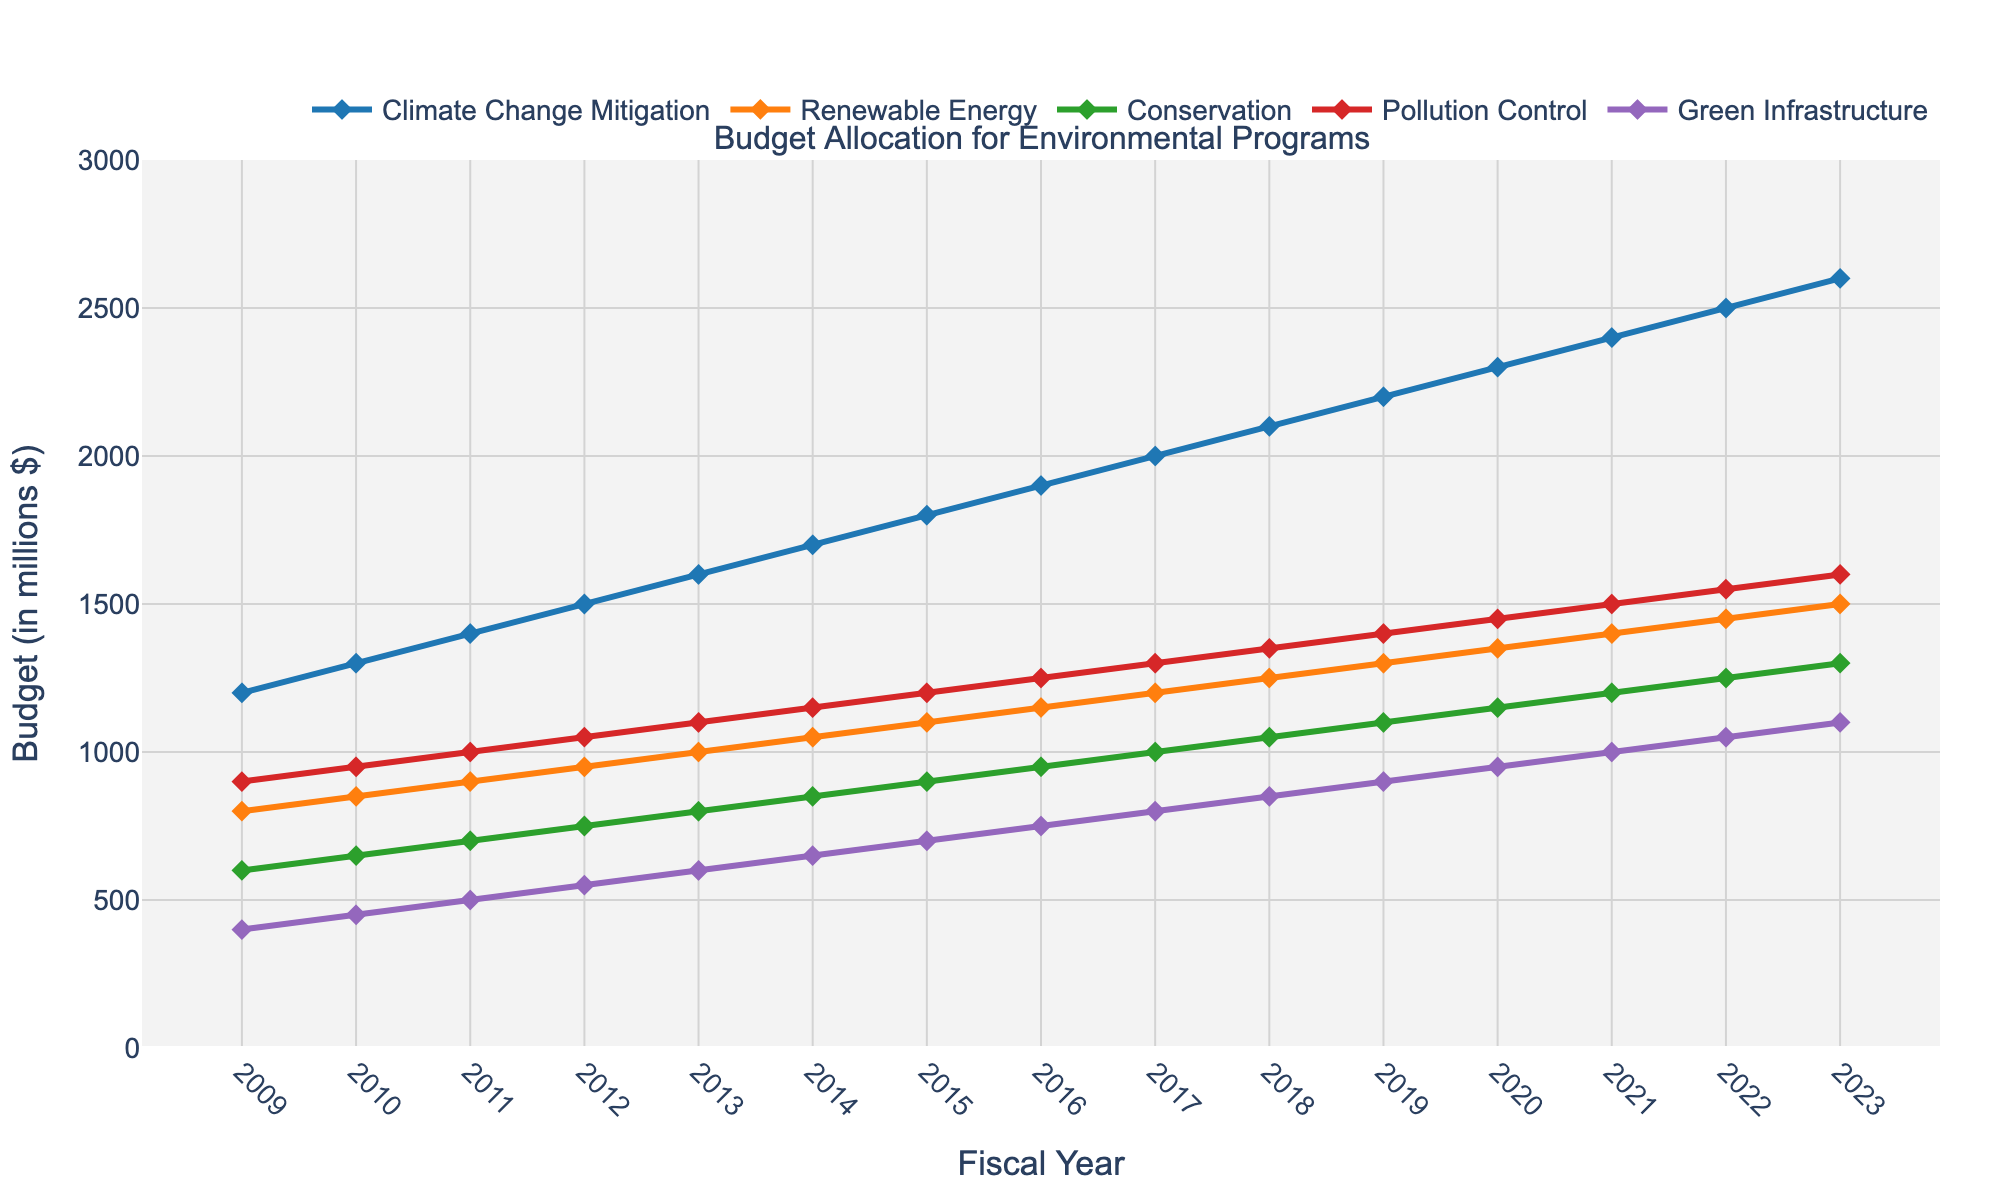What is the total budget allocated for Climate Change Mitigation in the first five fiscal years? To find the total budget for Climate Change Mitigation in the first five years, sum the values from 2009 to 2013: 1200 + 1300 + 1400 + 1500 + 1600 = 7000
Answer: 7000 Which year saw the largest budget increase for Renewable Energy when compared to the previous year? To identify the largest budget increase for Renewable Energy, compare the yearly differences: 
2010-2009 = 50, 
2011-2010 = 50, 
2012-2011 = 50, 
2013-2012 = 50, 
2014-2013 = 50, 
2015-2014 = 50, 
2016-2015 = 50, 
2017-2016 = 50, 
2018-2017 = 50, 
2019-2018 = 50, 
2020-2019 = 50, 
2021-2020 = 50, 
2022-2021 = 50, 
2023-2022 = 50. All the differences are equal, so any year can be chosen.
Answer: Any year from 2010 to 2023 By how much did the budget for Conservation in 2023 exceed the budget for Green Infrastructure in 2011? Subtract the 2011 budget for Green Infrastructure from the 2023 budget for Conservation: 1300 - 500 = 800
Answer: 800 What is the average annual budget for Pollution Control over the entire period? Sum the annual budgets from 2009 to 2023 and divide by the number of years: (900 + 950 + 1000 + 1050 + 1100 + 1150 + 1200 + 1250 + 1300 + 1350 + 1400 + 1450 + 1500 + 1550 + 1600) / 15 = 1250
Answer: 1250 Which program had the smallest budget in 2012, and what was that budget? To find the smallest budget in 2012, compare the values: 
Climate Change Mitigation = 1500, 
Renewable Energy = 950, 
Conservation = 750, 
Pollution Control = 1050, 
Green Infrastructure = 550. 
Green Infrastructure had the smallest budget with 550.
Answer: Green Infrastructure, 550 How did the budget allocation for Conservation change from 2016 to 2023? To find the change, subtract the 2016 budget from the 2023 budget for Conservation: 1300 - 950 = 350
Answer: Increased by 350 Comparing the budget values, which program had a higher budget in 2020: Renewable Energy or Pollution Control? Compare the budget values for 2020: 
Renewable Energy = 1350, 
Pollution Control = 1450. 
Pollution Control was higher.
Answer: Pollution Control In which fiscal year did the budget for Green Infrastructure first reach 1000 million dollars or more? Identify the first year where the Green Infrastructure budget is at least 1000: 2021, with a budget of 1000.
Answer: 2021 Which program had the highest overall budget in 2023, and what was that budget? To find the program with the highest budget in 2023, compare the values: 
Climate Change Mitigation = 2600, 
Renewable Energy = 1500, 
Conservation = 1300, 
Pollution Control = 1600, 
Green Infrastructure = 1100. Climate Change Mitigation had the highest budget with 2600.
Answer: Climate Change Mitigation, 2600 